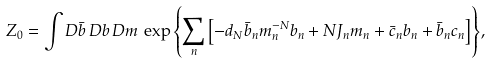Convert formula to latex. <formula><loc_0><loc_0><loc_500><loc_500>Z _ { 0 } = \int D \bar { b } \, D b \, D m \, \exp { \left \{ \sum _ { n } \left [ - d _ { N } \bar { b } _ { n } m ^ { - N } _ { n } b _ { n } + N J _ { n } m _ { n } + \bar { c } _ { n } b _ { n } + \bar { b } _ { n } c _ { n } \right ] \right \} } ,</formula> 